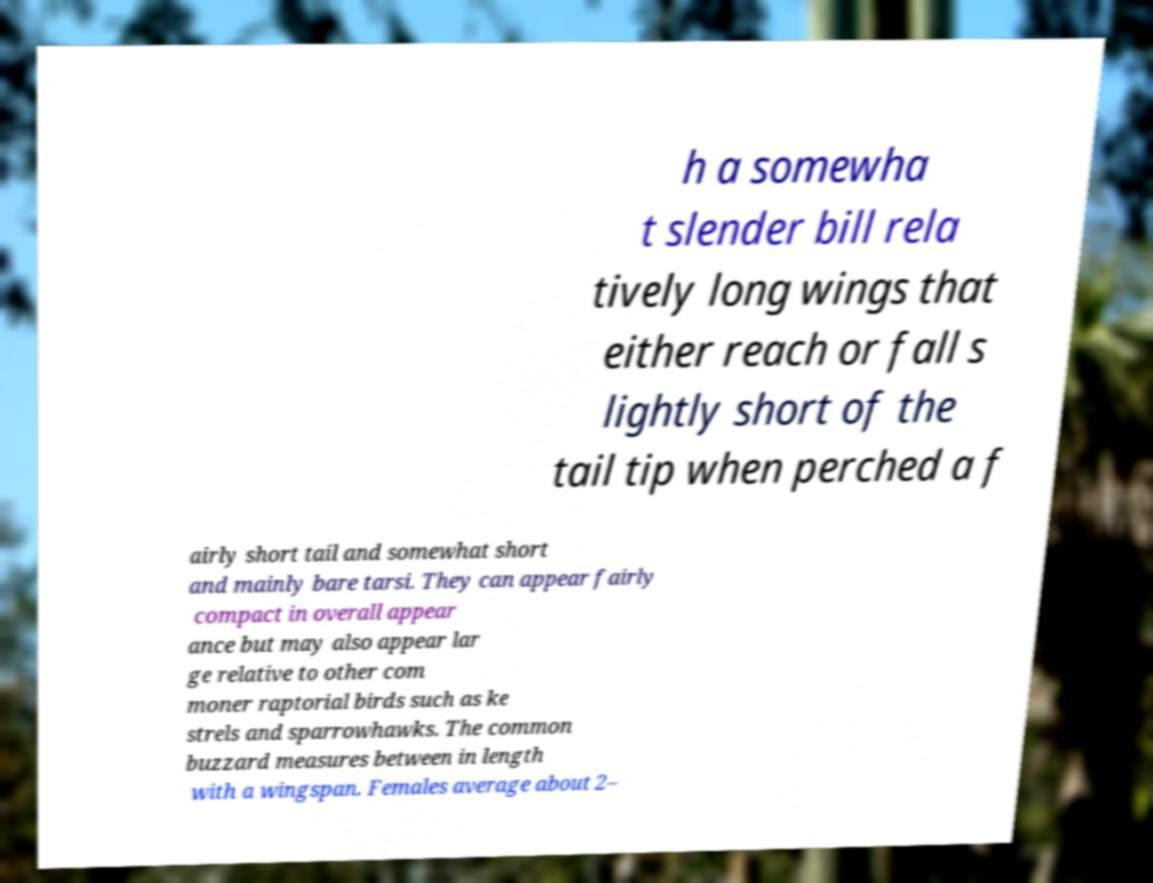Please read and relay the text visible in this image. What does it say? h a somewha t slender bill rela tively long wings that either reach or fall s lightly short of the tail tip when perched a f airly short tail and somewhat short and mainly bare tarsi. They can appear fairly compact in overall appear ance but may also appear lar ge relative to other com moner raptorial birds such as ke strels and sparrowhawks. The common buzzard measures between in length with a wingspan. Females average about 2– 